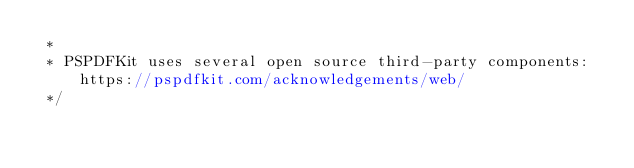Convert code to text. <code><loc_0><loc_0><loc_500><loc_500><_JavaScript_> * 
 * PSPDFKit uses several open source third-party components: https://pspdfkit.com/acknowledgements/web/
 */</code> 